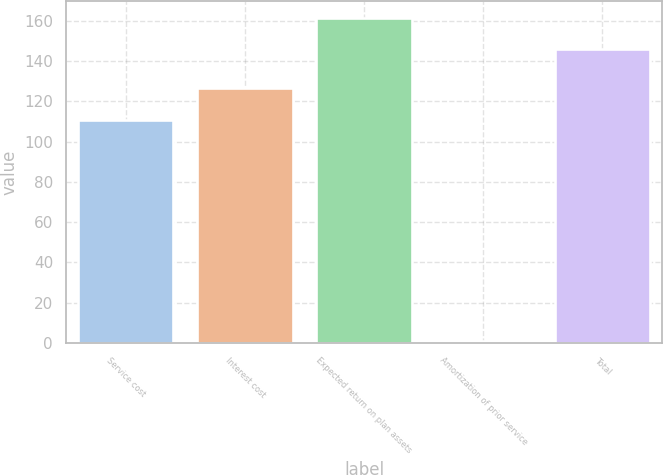Convert chart. <chart><loc_0><loc_0><loc_500><loc_500><bar_chart><fcel>Service cost<fcel>Interest cost<fcel>Expected return on plan assets<fcel>Amortization of prior service<fcel>Total<nl><fcel>111<fcel>126.6<fcel>161.6<fcel>1<fcel>146<nl></chart> 